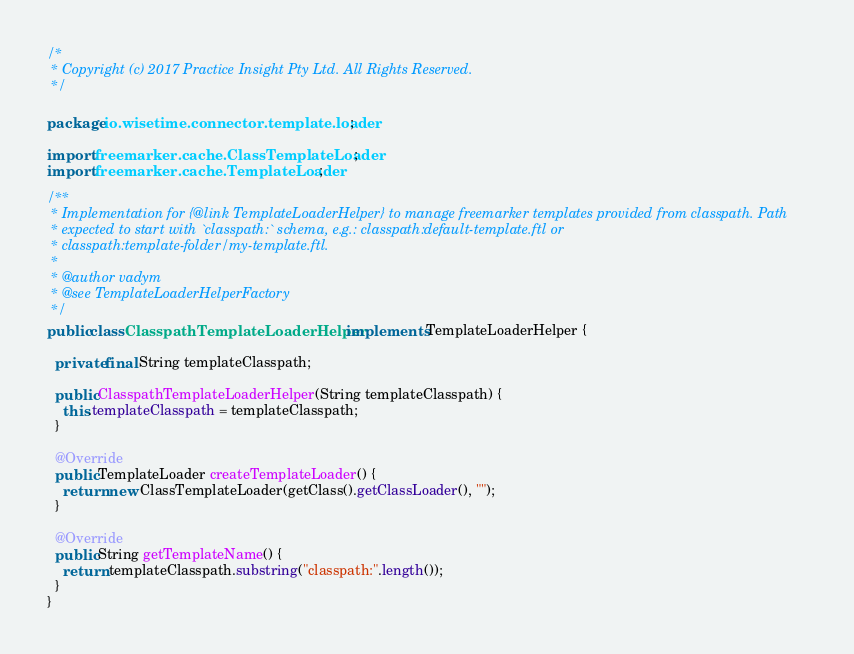<code> <loc_0><loc_0><loc_500><loc_500><_Java_>/*
 * Copyright (c) 2017 Practice Insight Pty Ltd. All Rights Reserved.
 */

package io.wisetime.connector.template.loader;

import freemarker.cache.ClassTemplateLoader;
import freemarker.cache.TemplateLoader;

/**
 * Implementation for {@link TemplateLoaderHelper} to manage freemarker templates provided from classpath. Path
 * expected to start with `classpath:` schema, e.g.: classpath:default-template.ftl or
 * classpath:template-folder/my-template.ftl.
 *
 * @author vadym
 * @see TemplateLoaderHelperFactory
 */
public class ClasspathTemplateLoaderHelper implements TemplateLoaderHelper {

  private final String templateClasspath;

  public ClasspathTemplateLoaderHelper(String templateClasspath) {
    this.templateClasspath = templateClasspath;
  }

  @Override
  public TemplateLoader createTemplateLoader() {
    return new ClassTemplateLoader(getClass().getClassLoader(), "");
  }

  @Override
  public String getTemplateName() {
    return templateClasspath.substring("classpath:".length());
  }
}
</code> 